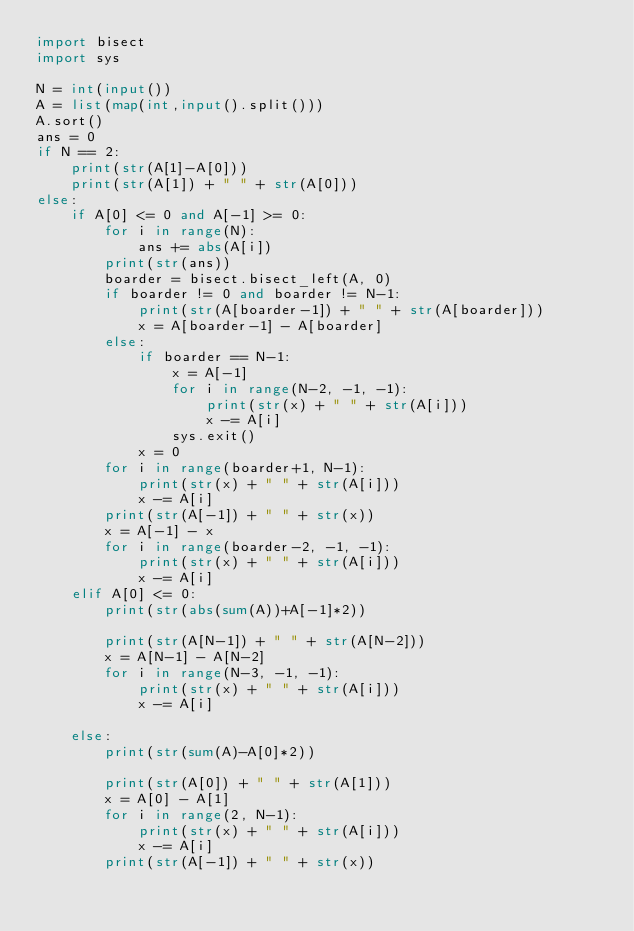<code> <loc_0><loc_0><loc_500><loc_500><_Python_>import bisect
import sys

N = int(input())
A = list(map(int,input().split()))
A.sort()
ans = 0
if N == 2:
    print(str(A[1]-A[0]))
    print(str(A[1]) + " " + str(A[0]))
else:
    if A[0] <= 0 and A[-1] >= 0:
        for i in range(N):
            ans += abs(A[i])
        print(str(ans))
        boarder = bisect.bisect_left(A, 0)
        if boarder != 0 and boarder != N-1:
            print(str(A[boarder-1]) + " " + str(A[boarder]))
            x = A[boarder-1] - A[boarder]
        else:
            if boarder == N-1:
                x = A[-1]
                for i in range(N-2, -1, -1):
                    print(str(x) + " " + str(A[i]))
                    x -= A[i]
                sys.exit()
            x = 0
        for i in range(boarder+1, N-1):
            print(str(x) + " " + str(A[i]))
            x -= A[i]
        print(str(A[-1]) + " " + str(x))
        x = A[-1] - x
        for i in range(boarder-2, -1, -1):
            print(str(x) + " " + str(A[i]))
            x -= A[i]
    elif A[0] <= 0:
        print(str(abs(sum(A))+A[-1]*2))
        
        print(str(A[N-1]) + " " + str(A[N-2]))
        x = A[N-1] - A[N-2]
        for i in range(N-3, -1, -1):
            print(str(x) + " " + str(A[i]))
            x -= A[i]
        
    else:
        print(str(sum(A)-A[0]*2))

        print(str(A[0]) + " " + str(A[1]))
        x = A[0] - A[1]
        for i in range(2, N-1):
            print(str(x) + " " + str(A[i]))
            x -= A[i]
        print(str(A[-1]) + " " + str(x))</code> 